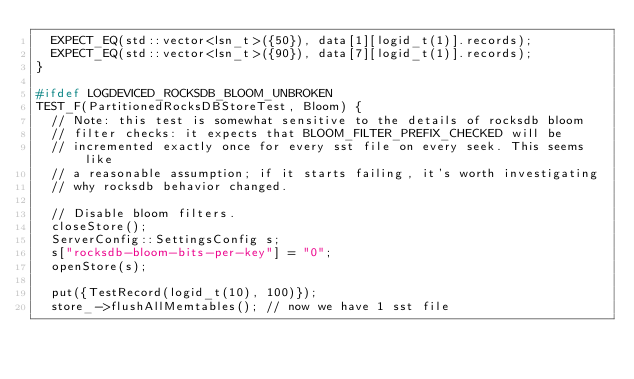<code> <loc_0><loc_0><loc_500><loc_500><_C++_>  EXPECT_EQ(std::vector<lsn_t>({50}), data[1][logid_t(1)].records);
  EXPECT_EQ(std::vector<lsn_t>({90}), data[7][logid_t(1)].records);
}

#ifdef LOGDEVICED_ROCKSDB_BLOOM_UNBROKEN
TEST_F(PartitionedRocksDBStoreTest, Bloom) {
  // Note: this test is somewhat sensitive to the details of rocksdb bloom
  // filter checks: it expects that BLOOM_FILTER_PREFIX_CHECKED will be
  // incremented exactly once for every sst file on every seek. This seems like
  // a reasonable assumption; if it starts failing, it's worth investigating
  // why rocksdb behavior changed.

  // Disable bloom filters.
  closeStore();
  ServerConfig::SettingsConfig s;
  s["rocksdb-bloom-bits-per-key"] = "0";
  openStore(s);

  put({TestRecord(logid_t(10), 100)});
  store_->flushAllMemtables(); // now we have 1 sst file
</code> 